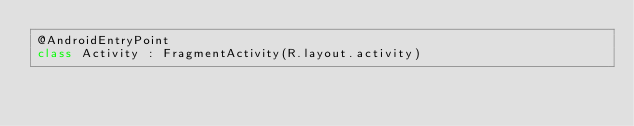Convert code to text. <code><loc_0><loc_0><loc_500><loc_500><_Kotlin_>@AndroidEntryPoint
class Activity : FragmentActivity(R.layout.activity)
</code> 